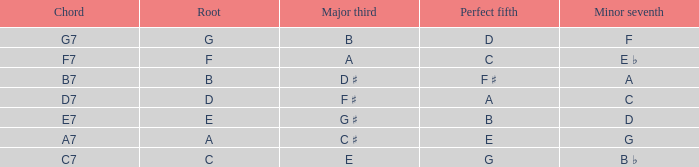What is the Chord with a Major that is third of e? C7. 